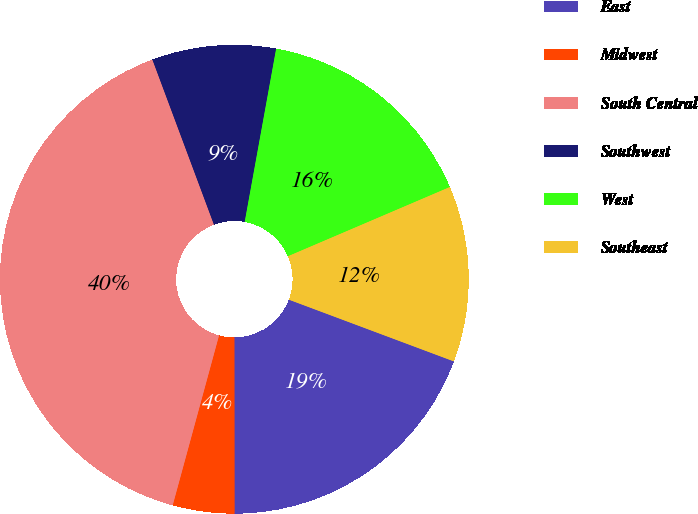Convert chart to OTSL. <chart><loc_0><loc_0><loc_500><loc_500><pie_chart><fcel>East<fcel>Midwest<fcel>South Central<fcel>Southwest<fcel>West<fcel>Southeast<nl><fcel>19.29%<fcel>4.25%<fcel>40.08%<fcel>8.54%<fcel>15.71%<fcel>12.13%<nl></chart> 